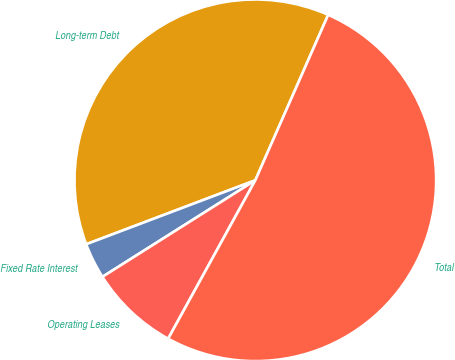Convert chart to OTSL. <chart><loc_0><loc_0><loc_500><loc_500><pie_chart><fcel>Long-term Debt<fcel>Fixed Rate Interest<fcel>Operating Leases<fcel>Total<nl><fcel>37.36%<fcel>3.21%<fcel>8.03%<fcel>51.41%<nl></chart> 